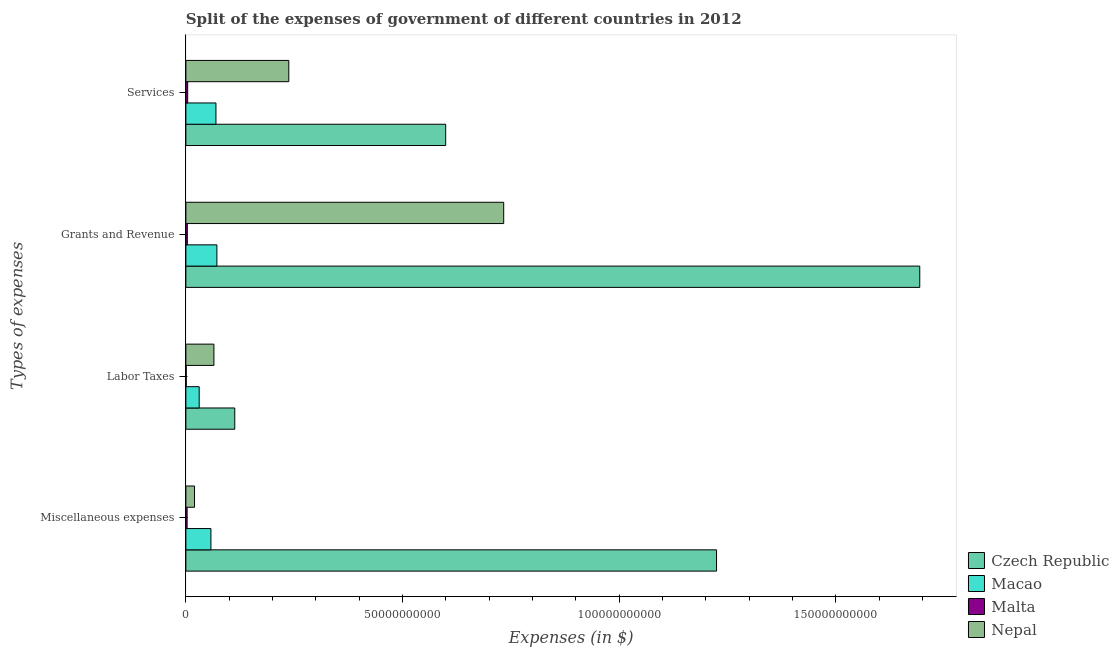How many different coloured bars are there?
Provide a succinct answer. 4. How many groups of bars are there?
Ensure brevity in your answer.  4. Are the number of bars on each tick of the Y-axis equal?
Your answer should be very brief. Yes. How many bars are there on the 3rd tick from the top?
Keep it short and to the point. 4. How many bars are there on the 2nd tick from the bottom?
Offer a terse response. 4. What is the label of the 2nd group of bars from the top?
Offer a terse response. Grants and Revenue. What is the amount spent on services in Macao?
Offer a very short reply. 6.94e+09. Across all countries, what is the maximum amount spent on services?
Your answer should be compact. 6.00e+1. Across all countries, what is the minimum amount spent on labor taxes?
Give a very brief answer. 7.98e+07. In which country was the amount spent on miscellaneous expenses maximum?
Your response must be concise. Czech Republic. In which country was the amount spent on labor taxes minimum?
Your answer should be compact. Malta. What is the total amount spent on services in the graph?
Your answer should be compact. 9.11e+1. What is the difference between the amount spent on services in Nepal and that in Malta?
Your answer should be very brief. 2.33e+1. What is the difference between the amount spent on services in Nepal and the amount spent on miscellaneous expenses in Czech Republic?
Give a very brief answer. -9.87e+1. What is the average amount spent on grants and revenue per country?
Your answer should be very brief. 6.25e+1. What is the difference between the amount spent on labor taxes and amount spent on services in Czech Republic?
Make the answer very short. -4.87e+1. In how many countries, is the amount spent on labor taxes greater than 100000000000 $?
Keep it short and to the point. 0. What is the ratio of the amount spent on labor taxes in Macao to that in Nepal?
Offer a terse response. 0.48. Is the amount spent on miscellaneous expenses in Czech Republic less than that in Nepal?
Offer a terse response. No. What is the difference between the highest and the second highest amount spent on services?
Ensure brevity in your answer.  3.62e+1. What is the difference between the highest and the lowest amount spent on grants and revenue?
Make the answer very short. 1.69e+11. In how many countries, is the amount spent on grants and revenue greater than the average amount spent on grants and revenue taken over all countries?
Your response must be concise. 2. What does the 1st bar from the top in Services represents?
Keep it short and to the point. Nepal. What does the 3rd bar from the bottom in Labor Taxes represents?
Offer a terse response. Malta. Is it the case that in every country, the sum of the amount spent on miscellaneous expenses and amount spent on labor taxes is greater than the amount spent on grants and revenue?
Ensure brevity in your answer.  No. How many bars are there?
Keep it short and to the point. 16. Are all the bars in the graph horizontal?
Make the answer very short. Yes. Are the values on the major ticks of X-axis written in scientific E-notation?
Keep it short and to the point. No. Does the graph contain any zero values?
Make the answer very short. No. Where does the legend appear in the graph?
Offer a terse response. Bottom right. How are the legend labels stacked?
Keep it short and to the point. Vertical. What is the title of the graph?
Your answer should be compact. Split of the expenses of government of different countries in 2012. What is the label or title of the X-axis?
Ensure brevity in your answer.  Expenses (in $). What is the label or title of the Y-axis?
Your answer should be compact. Types of expenses. What is the Expenses (in $) of Czech Republic in Miscellaneous expenses?
Provide a short and direct response. 1.22e+11. What is the Expenses (in $) in Macao in Miscellaneous expenses?
Provide a short and direct response. 5.78e+09. What is the Expenses (in $) of Malta in Miscellaneous expenses?
Ensure brevity in your answer.  2.84e+08. What is the Expenses (in $) of Nepal in Miscellaneous expenses?
Offer a terse response. 2.00e+09. What is the Expenses (in $) of Czech Republic in Labor Taxes?
Provide a short and direct response. 1.13e+1. What is the Expenses (in $) of Macao in Labor Taxes?
Give a very brief answer. 3.07e+09. What is the Expenses (in $) of Malta in Labor Taxes?
Keep it short and to the point. 7.98e+07. What is the Expenses (in $) of Nepal in Labor Taxes?
Keep it short and to the point. 6.47e+09. What is the Expenses (in $) of Czech Republic in Grants and Revenue?
Offer a terse response. 1.69e+11. What is the Expenses (in $) in Macao in Grants and Revenue?
Give a very brief answer. 7.16e+09. What is the Expenses (in $) in Malta in Grants and Revenue?
Your answer should be very brief. 3.30e+08. What is the Expenses (in $) in Nepal in Grants and Revenue?
Provide a short and direct response. 7.33e+1. What is the Expenses (in $) in Czech Republic in Services?
Offer a very short reply. 6.00e+1. What is the Expenses (in $) in Macao in Services?
Your response must be concise. 6.94e+09. What is the Expenses (in $) of Malta in Services?
Ensure brevity in your answer.  4.14e+08. What is the Expenses (in $) in Nepal in Services?
Make the answer very short. 2.38e+1. Across all Types of expenses, what is the maximum Expenses (in $) of Czech Republic?
Make the answer very short. 1.69e+11. Across all Types of expenses, what is the maximum Expenses (in $) in Macao?
Your answer should be compact. 7.16e+09. Across all Types of expenses, what is the maximum Expenses (in $) in Malta?
Keep it short and to the point. 4.14e+08. Across all Types of expenses, what is the maximum Expenses (in $) in Nepal?
Give a very brief answer. 7.33e+1. Across all Types of expenses, what is the minimum Expenses (in $) of Czech Republic?
Provide a short and direct response. 1.13e+1. Across all Types of expenses, what is the minimum Expenses (in $) in Macao?
Your response must be concise. 3.07e+09. Across all Types of expenses, what is the minimum Expenses (in $) of Malta?
Your answer should be compact. 7.98e+07. Across all Types of expenses, what is the minimum Expenses (in $) of Nepal?
Keep it short and to the point. 2.00e+09. What is the total Expenses (in $) in Czech Republic in the graph?
Your response must be concise. 3.63e+11. What is the total Expenses (in $) of Macao in the graph?
Your answer should be very brief. 2.30e+1. What is the total Expenses (in $) of Malta in the graph?
Provide a succinct answer. 1.11e+09. What is the total Expenses (in $) of Nepal in the graph?
Offer a very short reply. 1.06e+11. What is the difference between the Expenses (in $) of Czech Republic in Miscellaneous expenses and that in Labor Taxes?
Ensure brevity in your answer.  1.11e+11. What is the difference between the Expenses (in $) of Macao in Miscellaneous expenses and that in Labor Taxes?
Offer a terse response. 2.71e+09. What is the difference between the Expenses (in $) in Malta in Miscellaneous expenses and that in Labor Taxes?
Provide a short and direct response. 2.04e+08. What is the difference between the Expenses (in $) of Nepal in Miscellaneous expenses and that in Labor Taxes?
Offer a very short reply. -4.47e+09. What is the difference between the Expenses (in $) of Czech Republic in Miscellaneous expenses and that in Grants and Revenue?
Your response must be concise. -4.69e+1. What is the difference between the Expenses (in $) in Macao in Miscellaneous expenses and that in Grants and Revenue?
Your answer should be compact. -1.37e+09. What is the difference between the Expenses (in $) of Malta in Miscellaneous expenses and that in Grants and Revenue?
Provide a succinct answer. -4.66e+07. What is the difference between the Expenses (in $) in Nepal in Miscellaneous expenses and that in Grants and Revenue?
Provide a succinct answer. -7.13e+1. What is the difference between the Expenses (in $) of Czech Republic in Miscellaneous expenses and that in Services?
Offer a terse response. 6.25e+1. What is the difference between the Expenses (in $) of Macao in Miscellaneous expenses and that in Services?
Ensure brevity in your answer.  -1.16e+09. What is the difference between the Expenses (in $) of Malta in Miscellaneous expenses and that in Services?
Offer a terse response. -1.30e+08. What is the difference between the Expenses (in $) of Nepal in Miscellaneous expenses and that in Services?
Offer a very short reply. -2.18e+1. What is the difference between the Expenses (in $) of Czech Republic in Labor Taxes and that in Grants and Revenue?
Offer a terse response. -1.58e+11. What is the difference between the Expenses (in $) of Macao in Labor Taxes and that in Grants and Revenue?
Offer a terse response. -4.08e+09. What is the difference between the Expenses (in $) of Malta in Labor Taxes and that in Grants and Revenue?
Give a very brief answer. -2.51e+08. What is the difference between the Expenses (in $) in Nepal in Labor Taxes and that in Grants and Revenue?
Provide a succinct answer. -6.69e+1. What is the difference between the Expenses (in $) in Czech Republic in Labor Taxes and that in Services?
Make the answer very short. -4.87e+1. What is the difference between the Expenses (in $) of Macao in Labor Taxes and that in Services?
Your response must be concise. -3.87e+09. What is the difference between the Expenses (in $) of Malta in Labor Taxes and that in Services?
Offer a terse response. -3.35e+08. What is the difference between the Expenses (in $) in Nepal in Labor Taxes and that in Services?
Your response must be concise. -1.73e+1. What is the difference between the Expenses (in $) of Czech Republic in Grants and Revenue and that in Services?
Provide a short and direct response. 1.09e+11. What is the difference between the Expenses (in $) in Macao in Grants and Revenue and that in Services?
Your response must be concise. 2.15e+08. What is the difference between the Expenses (in $) in Malta in Grants and Revenue and that in Services?
Give a very brief answer. -8.39e+07. What is the difference between the Expenses (in $) in Nepal in Grants and Revenue and that in Services?
Provide a succinct answer. 4.96e+1. What is the difference between the Expenses (in $) in Czech Republic in Miscellaneous expenses and the Expenses (in $) in Macao in Labor Taxes?
Offer a very short reply. 1.19e+11. What is the difference between the Expenses (in $) of Czech Republic in Miscellaneous expenses and the Expenses (in $) of Malta in Labor Taxes?
Your answer should be very brief. 1.22e+11. What is the difference between the Expenses (in $) in Czech Republic in Miscellaneous expenses and the Expenses (in $) in Nepal in Labor Taxes?
Offer a terse response. 1.16e+11. What is the difference between the Expenses (in $) in Macao in Miscellaneous expenses and the Expenses (in $) in Malta in Labor Taxes?
Offer a very short reply. 5.70e+09. What is the difference between the Expenses (in $) of Macao in Miscellaneous expenses and the Expenses (in $) of Nepal in Labor Taxes?
Ensure brevity in your answer.  -6.86e+08. What is the difference between the Expenses (in $) of Malta in Miscellaneous expenses and the Expenses (in $) of Nepal in Labor Taxes?
Make the answer very short. -6.18e+09. What is the difference between the Expenses (in $) of Czech Republic in Miscellaneous expenses and the Expenses (in $) of Macao in Grants and Revenue?
Provide a short and direct response. 1.15e+11. What is the difference between the Expenses (in $) in Czech Republic in Miscellaneous expenses and the Expenses (in $) in Malta in Grants and Revenue?
Make the answer very short. 1.22e+11. What is the difference between the Expenses (in $) in Czech Republic in Miscellaneous expenses and the Expenses (in $) in Nepal in Grants and Revenue?
Give a very brief answer. 4.91e+1. What is the difference between the Expenses (in $) in Macao in Miscellaneous expenses and the Expenses (in $) in Malta in Grants and Revenue?
Offer a terse response. 5.45e+09. What is the difference between the Expenses (in $) of Macao in Miscellaneous expenses and the Expenses (in $) of Nepal in Grants and Revenue?
Offer a very short reply. -6.76e+1. What is the difference between the Expenses (in $) of Malta in Miscellaneous expenses and the Expenses (in $) of Nepal in Grants and Revenue?
Provide a succinct answer. -7.31e+1. What is the difference between the Expenses (in $) of Czech Republic in Miscellaneous expenses and the Expenses (in $) of Macao in Services?
Your answer should be compact. 1.16e+11. What is the difference between the Expenses (in $) of Czech Republic in Miscellaneous expenses and the Expenses (in $) of Malta in Services?
Ensure brevity in your answer.  1.22e+11. What is the difference between the Expenses (in $) in Czech Republic in Miscellaneous expenses and the Expenses (in $) in Nepal in Services?
Your answer should be compact. 9.87e+1. What is the difference between the Expenses (in $) of Macao in Miscellaneous expenses and the Expenses (in $) of Malta in Services?
Provide a succinct answer. 5.37e+09. What is the difference between the Expenses (in $) in Macao in Miscellaneous expenses and the Expenses (in $) in Nepal in Services?
Your answer should be compact. -1.80e+1. What is the difference between the Expenses (in $) in Malta in Miscellaneous expenses and the Expenses (in $) in Nepal in Services?
Provide a succinct answer. -2.35e+1. What is the difference between the Expenses (in $) of Czech Republic in Labor Taxes and the Expenses (in $) of Macao in Grants and Revenue?
Keep it short and to the point. 4.13e+09. What is the difference between the Expenses (in $) of Czech Republic in Labor Taxes and the Expenses (in $) of Malta in Grants and Revenue?
Offer a very short reply. 1.10e+1. What is the difference between the Expenses (in $) of Czech Republic in Labor Taxes and the Expenses (in $) of Nepal in Grants and Revenue?
Keep it short and to the point. -6.21e+1. What is the difference between the Expenses (in $) of Macao in Labor Taxes and the Expenses (in $) of Malta in Grants and Revenue?
Make the answer very short. 2.74e+09. What is the difference between the Expenses (in $) of Macao in Labor Taxes and the Expenses (in $) of Nepal in Grants and Revenue?
Offer a very short reply. -7.03e+1. What is the difference between the Expenses (in $) in Malta in Labor Taxes and the Expenses (in $) in Nepal in Grants and Revenue?
Your answer should be very brief. -7.33e+1. What is the difference between the Expenses (in $) of Czech Republic in Labor Taxes and the Expenses (in $) of Macao in Services?
Ensure brevity in your answer.  4.34e+09. What is the difference between the Expenses (in $) in Czech Republic in Labor Taxes and the Expenses (in $) in Malta in Services?
Provide a short and direct response. 1.09e+1. What is the difference between the Expenses (in $) of Czech Republic in Labor Taxes and the Expenses (in $) of Nepal in Services?
Give a very brief answer. -1.25e+1. What is the difference between the Expenses (in $) in Macao in Labor Taxes and the Expenses (in $) in Malta in Services?
Offer a terse response. 2.66e+09. What is the difference between the Expenses (in $) of Macao in Labor Taxes and the Expenses (in $) of Nepal in Services?
Offer a very short reply. -2.07e+1. What is the difference between the Expenses (in $) of Malta in Labor Taxes and the Expenses (in $) of Nepal in Services?
Your answer should be compact. -2.37e+1. What is the difference between the Expenses (in $) in Czech Republic in Grants and Revenue and the Expenses (in $) in Macao in Services?
Make the answer very short. 1.62e+11. What is the difference between the Expenses (in $) in Czech Republic in Grants and Revenue and the Expenses (in $) in Malta in Services?
Keep it short and to the point. 1.69e+11. What is the difference between the Expenses (in $) of Czech Republic in Grants and Revenue and the Expenses (in $) of Nepal in Services?
Make the answer very short. 1.46e+11. What is the difference between the Expenses (in $) in Macao in Grants and Revenue and the Expenses (in $) in Malta in Services?
Offer a very short reply. 6.74e+09. What is the difference between the Expenses (in $) of Macao in Grants and Revenue and the Expenses (in $) of Nepal in Services?
Offer a terse response. -1.66e+1. What is the difference between the Expenses (in $) of Malta in Grants and Revenue and the Expenses (in $) of Nepal in Services?
Provide a short and direct response. -2.34e+1. What is the average Expenses (in $) in Czech Republic per Types of expenses?
Your answer should be very brief. 9.08e+1. What is the average Expenses (in $) of Macao per Types of expenses?
Provide a short and direct response. 5.74e+09. What is the average Expenses (in $) in Malta per Types of expenses?
Your answer should be compact. 2.77e+08. What is the average Expenses (in $) of Nepal per Types of expenses?
Provide a short and direct response. 2.64e+1. What is the difference between the Expenses (in $) in Czech Republic and Expenses (in $) in Macao in Miscellaneous expenses?
Make the answer very short. 1.17e+11. What is the difference between the Expenses (in $) in Czech Republic and Expenses (in $) in Malta in Miscellaneous expenses?
Make the answer very short. 1.22e+11. What is the difference between the Expenses (in $) in Czech Republic and Expenses (in $) in Nepal in Miscellaneous expenses?
Provide a short and direct response. 1.20e+11. What is the difference between the Expenses (in $) in Macao and Expenses (in $) in Malta in Miscellaneous expenses?
Give a very brief answer. 5.50e+09. What is the difference between the Expenses (in $) in Macao and Expenses (in $) in Nepal in Miscellaneous expenses?
Give a very brief answer. 3.78e+09. What is the difference between the Expenses (in $) of Malta and Expenses (in $) of Nepal in Miscellaneous expenses?
Give a very brief answer. -1.71e+09. What is the difference between the Expenses (in $) of Czech Republic and Expenses (in $) of Macao in Labor Taxes?
Your answer should be compact. 8.21e+09. What is the difference between the Expenses (in $) of Czech Republic and Expenses (in $) of Malta in Labor Taxes?
Your response must be concise. 1.12e+1. What is the difference between the Expenses (in $) in Czech Republic and Expenses (in $) in Nepal in Labor Taxes?
Make the answer very short. 4.81e+09. What is the difference between the Expenses (in $) in Macao and Expenses (in $) in Malta in Labor Taxes?
Provide a succinct answer. 2.99e+09. What is the difference between the Expenses (in $) in Macao and Expenses (in $) in Nepal in Labor Taxes?
Keep it short and to the point. -3.39e+09. What is the difference between the Expenses (in $) in Malta and Expenses (in $) in Nepal in Labor Taxes?
Make the answer very short. -6.39e+09. What is the difference between the Expenses (in $) of Czech Republic and Expenses (in $) of Macao in Grants and Revenue?
Give a very brief answer. 1.62e+11. What is the difference between the Expenses (in $) in Czech Republic and Expenses (in $) in Malta in Grants and Revenue?
Offer a very short reply. 1.69e+11. What is the difference between the Expenses (in $) of Czech Republic and Expenses (in $) of Nepal in Grants and Revenue?
Your answer should be very brief. 9.60e+1. What is the difference between the Expenses (in $) in Macao and Expenses (in $) in Malta in Grants and Revenue?
Your answer should be compact. 6.83e+09. What is the difference between the Expenses (in $) of Macao and Expenses (in $) of Nepal in Grants and Revenue?
Keep it short and to the point. -6.62e+1. What is the difference between the Expenses (in $) of Malta and Expenses (in $) of Nepal in Grants and Revenue?
Ensure brevity in your answer.  -7.30e+1. What is the difference between the Expenses (in $) of Czech Republic and Expenses (in $) of Macao in Services?
Ensure brevity in your answer.  5.30e+1. What is the difference between the Expenses (in $) of Czech Republic and Expenses (in $) of Malta in Services?
Ensure brevity in your answer.  5.95e+1. What is the difference between the Expenses (in $) in Czech Republic and Expenses (in $) in Nepal in Services?
Offer a terse response. 3.62e+1. What is the difference between the Expenses (in $) of Macao and Expenses (in $) of Malta in Services?
Your response must be concise. 6.53e+09. What is the difference between the Expenses (in $) in Macao and Expenses (in $) in Nepal in Services?
Provide a succinct answer. -1.68e+1. What is the difference between the Expenses (in $) of Malta and Expenses (in $) of Nepal in Services?
Your response must be concise. -2.33e+1. What is the ratio of the Expenses (in $) of Czech Republic in Miscellaneous expenses to that in Labor Taxes?
Offer a terse response. 10.86. What is the ratio of the Expenses (in $) in Macao in Miscellaneous expenses to that in Labor Taxes?
Your answer should be compact. 1.88. What is the ratio of the Expenses (in $) in Malta in Miscellaneous expenses to that in Labor Taxes?
Give a very brief answer. 3.56. What is the ratio of the Expenses (in $) of Nepal in Miscellaneous expenses to that in Labor Taxes?
Make the answer very short. 0.31. What is the ratio of the Expenses (in $) in Czech Republic in Miscellaneous expenses to that in Grants and Revenue?
Give a very brief answer. 0.72. What is the ratio of the Expenses (in $) of Macao in Miscellaneous expenses to that in Grants and Revenue?
Provide a succinct answer. 0.81. What is the ratio of the Expenses (in $) in Malta in Miscellaneous expenses to that in Grants and Revenue?
Your answer should be compact. 0.86. What is the ratio of the Expenses (in $) in Nepal in Miscellaneous expenses to that in Grants and Revenue?
Provide a short and direct response. 0.03. What is the ratio of the Expenses (in $) in Czech Republic in Miscellaneous expenses to that in Services?
Make the answer very short. 2.04. What is the ratio of the Expenses (in $) of Macao in Miscellaneous expenses to that in Services?
Offer a terse response. 0.83. What is the ratio of the Expenses (in $) in Malta in Miscellaneous expenses to that in Services?
Give a very brief answer. 0.69. What is the ratio of the Expenses (in $) in Nepal in Miscellaneous expenses to that in Services?
Keep it short and to the point. 0.08. What is the ratio of the Expenses (in $) in Czech Republic in Labor Taxes to that in Grants and Revenue?
Provide a succinct answer. 0.07. What is the ratio of the Expenses (in $) in Macao in Labor Taxes to that in Grants and Revenue?
Offer a very short reply. 0.43. What is the ratio of the Expenses (in $) in Malta in Labor Taxes to that in Grants and Revenue?
Provide a succinct answer. 0.24. What is the ratio of the Expenses (in $) of Nepal in Labor Taxes to that in Grants and Revenue?
Your response must be concise. 0.09. What is the ratio of the Expenses (in $) of Czech Republic in Labor Taxes to that in Services?
Offer a very short reply. 0.19. What is the ratio of the Expenses (in $) in Macao in Labor Taxes to that in Services?
Make the answer very short. 0.44. What is the ratio of the Expenses (in $) of Malta in Labor Taxes to that in Services?
Keep it short and to the point. 0.19. What is the ratio of the Expenses (in $) in Nepal in Labor Taxes to that in Services?
Your response must be concise. 0.27. What is the ratio of the Expenses (in $) in Czech Republic in Grants and Revenue to that in Services?
Offer a very short reply. 2.82. What is the ratio of the Expenses (in $) in Macao in Grants and Revenue to that in Services?
Offer a terse response. 1.03. What is the ratio of the Expenses (in $) in Malta in Grants and Revenue to that in Services?
Offer a terse response. 0.8. What is the ratio of the Expenses (in $) in Nepal in Grants and Revenue to that in Services?
Your answer should be very brief. 3.09. What is the difference between the highest and the second highest Expenses (in $) in Czech Republic?
Keep it short and to the point. 4.69e+1. What is the difference between the highest and the second highest Expenses (in $) of Macao?
Offer a very short reply. 2.15e+08. What is the difference between the highest and the second highest Expenses (in $) of Malta?
Provide a short and direct response. 8.39e+07. What is the difference between the highest and the second highest Expenses (in $) in Nepal?
Ensure brevity in your answer.  4.96e+1. What is the difference between the highest and the lowest Expenses (in $) in Czech Republic?
Provide a succinct answer. 1.58e+11. What is the difference between the highest and the lowest Expenses (in $) in Macao?
Your answer should be compact. 4.08e+09. What is the difference between the highest and the lowest Expenses (in $) of Malta?
Provide a short and direct response. 3.35e+08. What is the difference between the highest and the lowest Expenses (in $) of Nepal?
Offer a very short reply. 7.13e+1. 